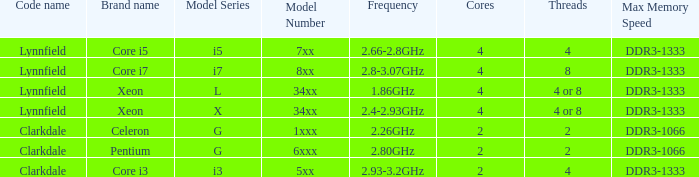List the number of cores for ddr3-1333 with frequencies between 2.66-2.8ghz. 4/4. 